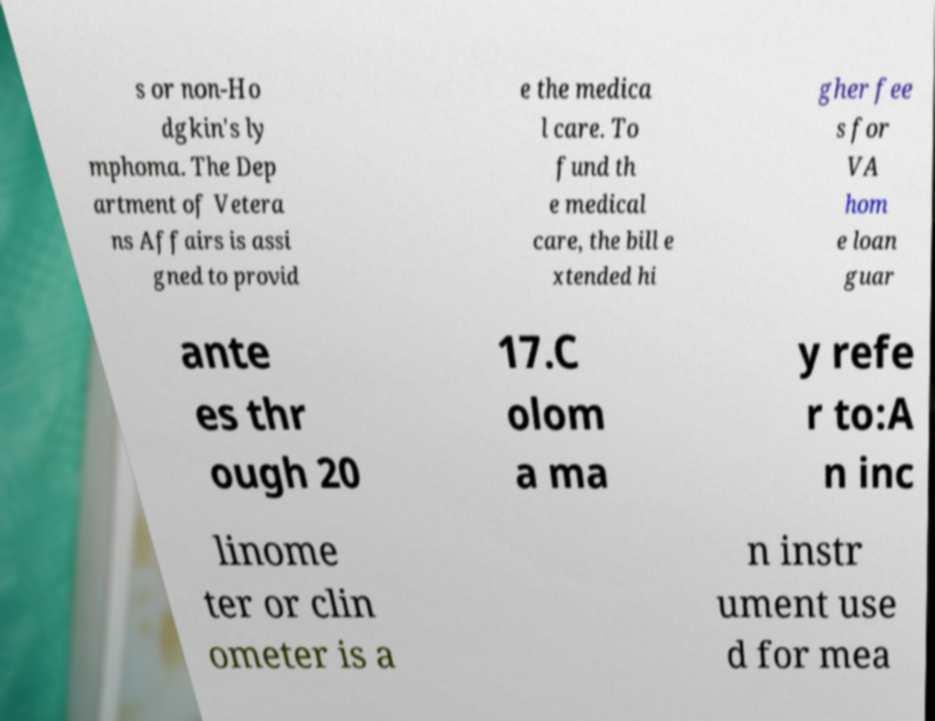Please identify and transcribe the text found in this image. s or non-Ho dgkin's ly mphoma. The Dep artment of Vetera ns Affairs is assi gned to provid e the medica l care. To fund th e medical care, the bill e xtended hi gher fee s for VA hom e loan guar ante es thr ough 20 17.C olom a ma y refe r to:A n inc linome ter or clin ometer is a n instr ument use d for mea 